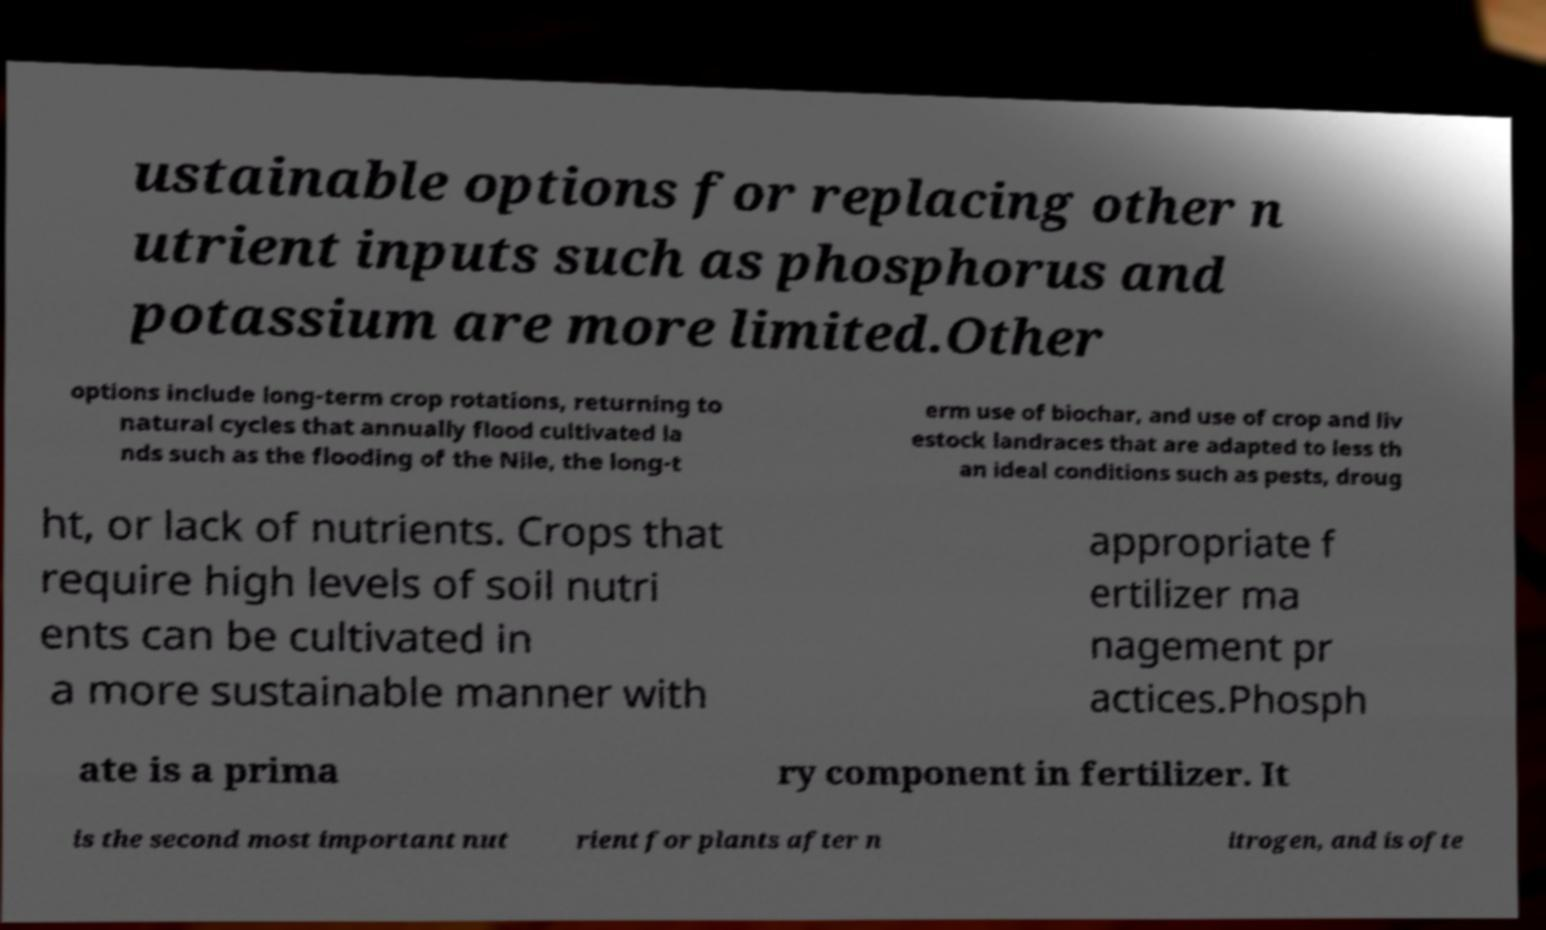I need the written content from this picture converted into text. Can you do that? ustainable options for replacing other n utrient inputs such as phosphorus and potassium are more limited.Other options include long-term crop rotations, returning to natural cycles that annually flood cultivated la nds such as the flooding of the Nile, the long-t erm use of biochar, and use of crop and liv estock landraces that are adapted to less th an ideal conditions such as pests, droug ht, or lack of nutrients. Crops that require high levels of soil nutri ents can be cultivated in a more sustainable manner with appropriate f ertilizer ma nagement pr actices.Phosph ate is a prima ry component in fertilizer. It is the second most important nut rient for plants after n itrogen, and is ofte 